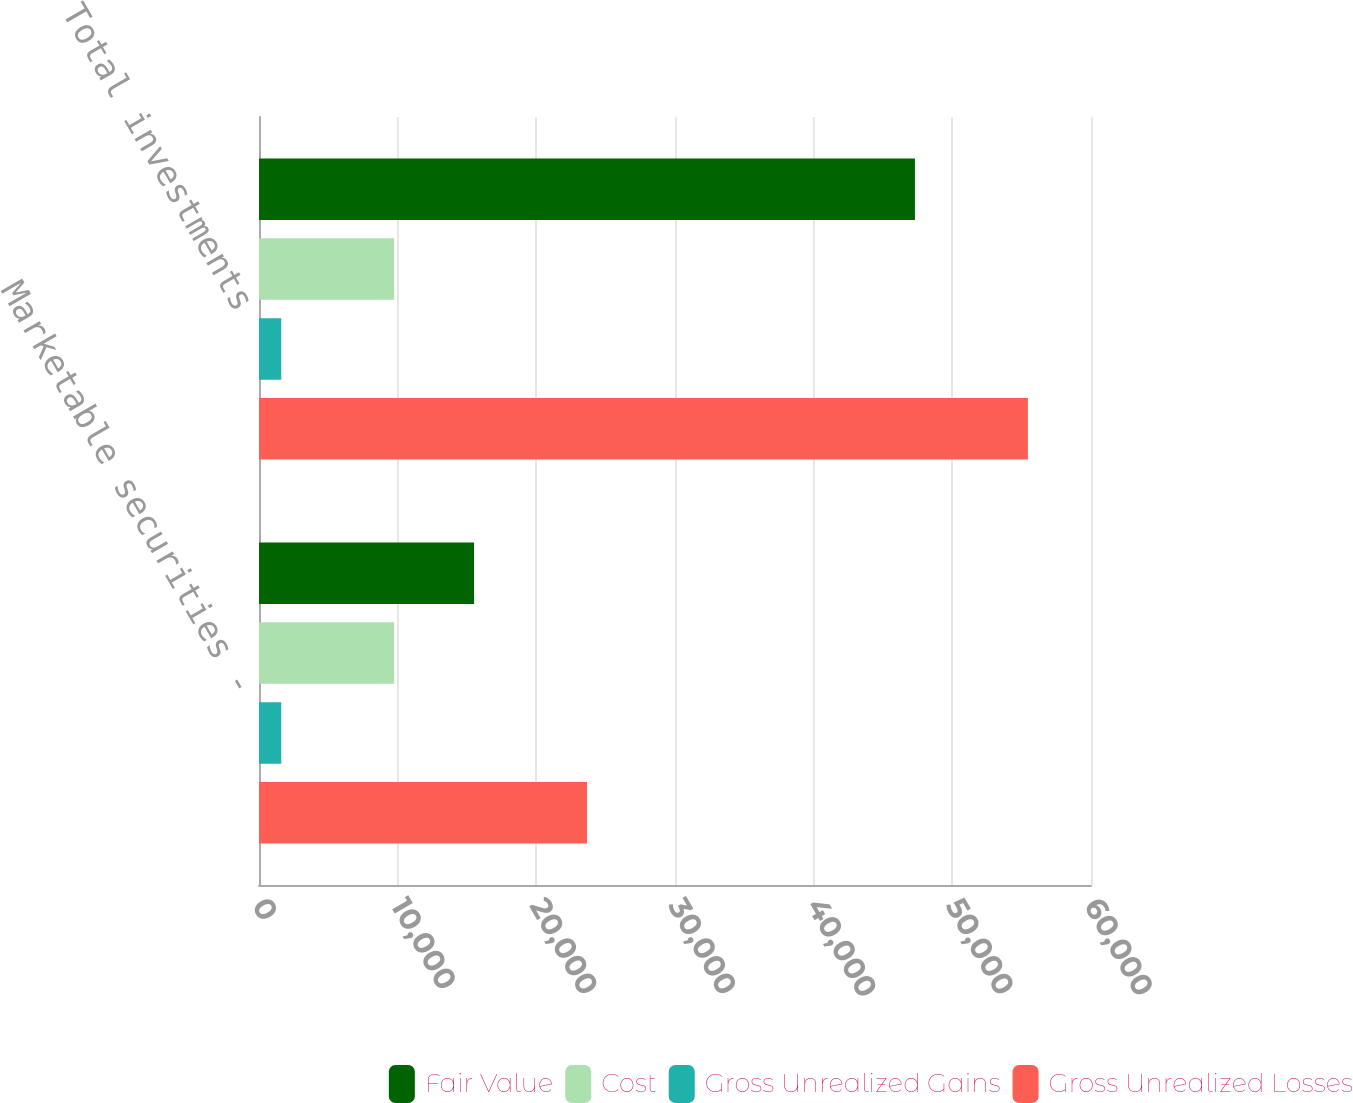Convert chart to OTSL. <chart><loc_0><loc_0><loc_500><loc_500><stacked_bar_chart><ecel><fcel>Marketable securities -<fcel>Total investments<nl><fcel>Fair Value<fcel>15510<fcel>47304<nl><fcel>Cost<fcel>9749<fcel>9749<nl><fcel>Gross Unrealized Gains<fcel>1604<fcel>1604<nl><fcel>Gross Unrealized Losses<fcel>23655<fcel>55449<nl></chart> 